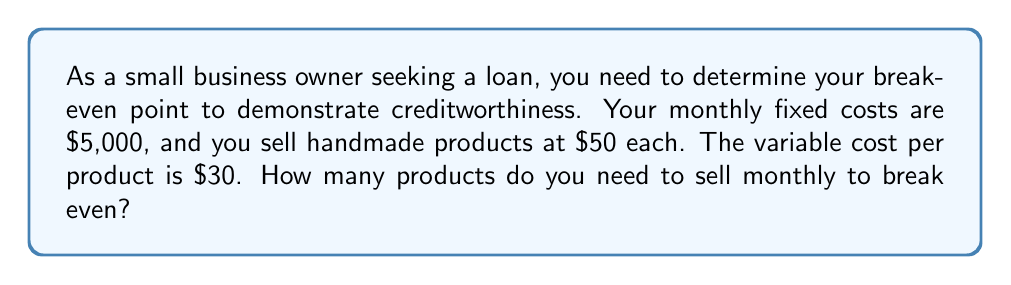Provide a solution to this math problem. To solve this problem, we'll use the break-even formula:

Break-even point = Fixed Costs / (Price per unit - Variable Cost per unit)

Let's define our variables:
- Fixed Costs (FC) = $5,000
- Price per unit (P) = $50
- Variable Cost per unit (VC) = $30

Step 1: Calculate the contribution margin per unit
Contribution margin = Price per unit - Variable Cost per unit
$$ CM = P - VC = 50 - 30 = 20 $$

Step 2: Apply the break-even formula
$$ \text{Break-even point} = \frac{FC}{CM} = \frac{5000}{20} = 250 $$

Step 3: Verify the result using the linear equation for total revenue and total cost
Let x be the number of units sold.

Total Revenue: $TR = 50x$
Total Cost: $TC = 5000 + 30x$

At the break-even point, TR = TC:

$$ 50x = 5000 + 30x $$
$$ 20x = 5000 $$
$$ x = 250 $$

This confirms our initial calculation.
Answer: 250 products 